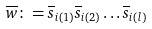<formula> <loc_0><loc_0><loc_500><loc_500>\overline { w } \colon = \overline { s } _ { i ( 1 ) } \overline { s } _ { i ( 2 ) } \dots \overline { s } _ { i ( l ) }</formula> 